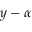Convert formula to latex. <formula><loc_0><loc_0><loc_500><loc_500>y - \alpha</formula> 